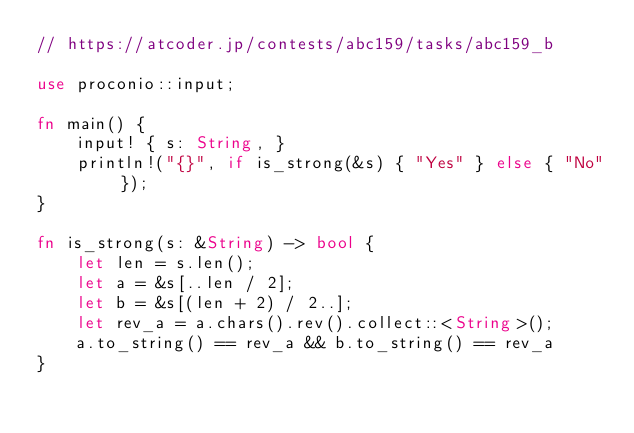<code> <loc_0><loc_0><loc_500><loc_500><_Rust_>// https://atcoder.jp/contests/abc159/tasks/abc159_b

use proconio::input;

fn main() {
    input! { s: String, }
    println!("{}", if is_strong(&s) { "Yes" } else { "No" });
}

fn is_strong(s: &String) -> bool {
    let len = s.len();
    let a = &s[..len / 2];
    let b = &s[(len + 2) / 2..];
    let rev_a = a.chars().rev().collect::<String>();
    a.to_string() == rev_a && b.to_string() == rev_a
}
</code> 